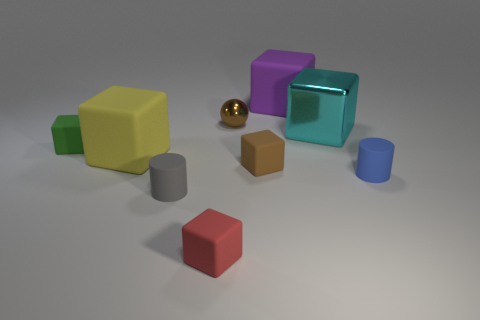Subtract all cyan cubes. How many cubes are left? 5 Subtract all green blocks. How many blocks are left? 5 Subtract all brown cubes. Subtract all blue cylinders. How many cubes are left? 5 Add 1 cyan objects. How many objects exist? 10 Subtract all cubes. How many objects are left? 3 Add 1 tiny matte objects. How many tiny matte objects are left? 6 Add 4 red things. How many red things exist? 5 Subtract 0 cyan cylinders. How many objects are left? 9 Subtract all metal blocks. Subtract all blue rubber objects. How many objects are left? 7 